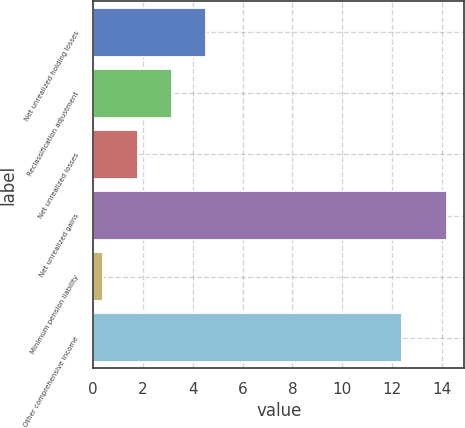Convert chart to OTSL. <chart><loc_0><loc_0><loc_500><loc_500><bar_chart><fcel>Net unrealized holding losses<fcel>Reclassification adjustment<fcel>Net unrealized losses<fcel>Net unrealized gains<fcel>Minimum pension liability<fcel>Other comprehensive income<nl><fcel>4.54<fcel>3.16<fcel>1.78<fcel>14.2<fcel>0.4<fcel>12.4<nl></chart> 